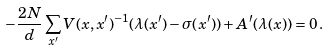<formula> <loc_0><loc_0><loc_500><loc_500>- \frac { 2 N } { d } \sum _ { x ^ { \prime } } V ( x , x ^ { \prime } ) ^ { - 1 } ( \lambda ( x ^ { \prime } ) - \sigma ( x ^ { \prime } ) ) + A ^ { \prime } ( \lambda ( x ) ) = 0 \, .</formula> 